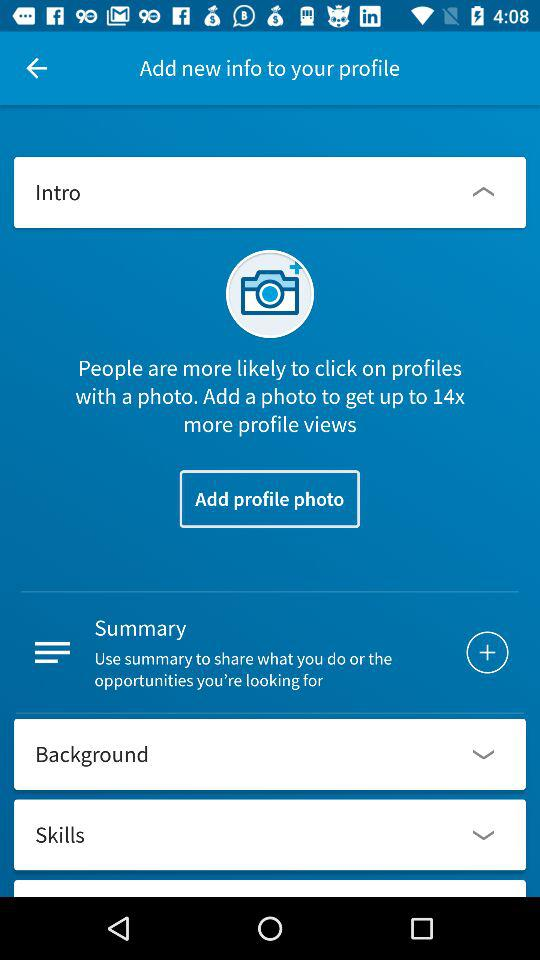How many profile fields are there for the user to fill out?
Answer the question using a single word or phrase. 4 